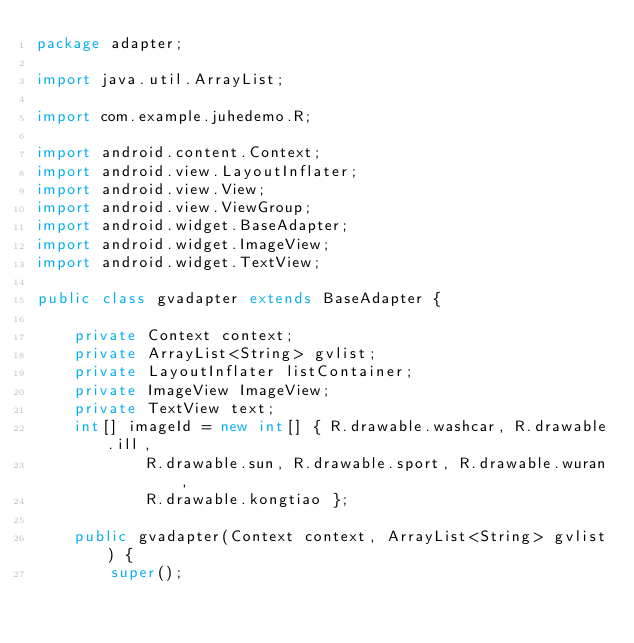<code> <loc_0><loc_0><loc_500><loc_500><_Java_>package adapter;

import java.util.ArrayList;

import com.example.juhedemo.R;

import android.content.Context;
import android.view.LayoutInflater;
import android.view.View;
import android.view.ViewGroup;
import android.widget.BaseAdapter;
import android.widget.ImageView;
import android.widget.TextView;

public class gvadapter extends BaseAdapter {

	private Context context;
	private ArrayList<String> gvlist;
	private LayoutInflater listContainer;
	private ImageView ImageView;
	private TextView text;
	int[] imageId = new int[] { R.drawable.washcar, R.drawable.ill,
			R.drawable.sun, R.drawable.sport, R.drawable.wuran,
			R.drawable.kongtiao };

	public gvadapter(Context context, ArrayList<String> gvlist) {
		super();</code> 